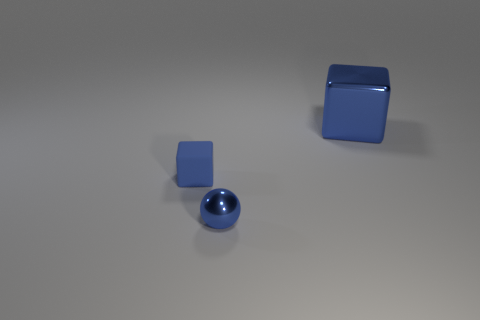The small object that is right of the blue cube that is to the left of the large shiny object is what color?
Ensure brevity in your answer.  Blue. Are there fewer small things right of the tiny blue rubber block than large objects in front of the tiny shiny ball?
Ensure brevity in your answer.  No. Does the shiny sphere have the same size as the rubber cube?
Offer a terse response. Yes. There is a blue thing that is behind the sphere and to the left of the large shiny thing; what is its shape?
Provide a short and direct response. Cube. What number of balls are made of the same material as the big blue object?
Your response must be concise. 1. What number of cubes are to the left of the blue metal object on the right side of the small metal thing?
Keep it short and to the point. 1. The metal object to the left of the metal object that is behind the tiny object behind the tiny metal ball is what shape?
Keep it short and to the point. Sphere. What size is the cube that is the same color as the tiny rubber thing?
Your answer should be compact. Large. How many things are blue metallic cubes or tiny matte objects?
Offer a very short reply. 2. There is another thing that is the same size as the rubber thing; what color is it?
Your answer should be very brief. Blue. 